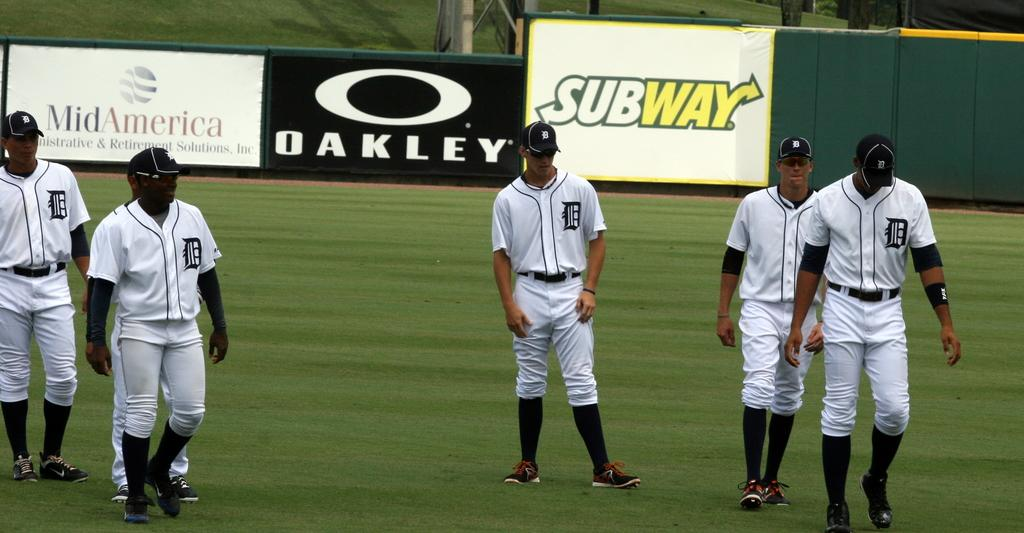Provide a one-sentence caption for the provided image. A group of baseball players wearing Detroit uniforms on a baseball field. 